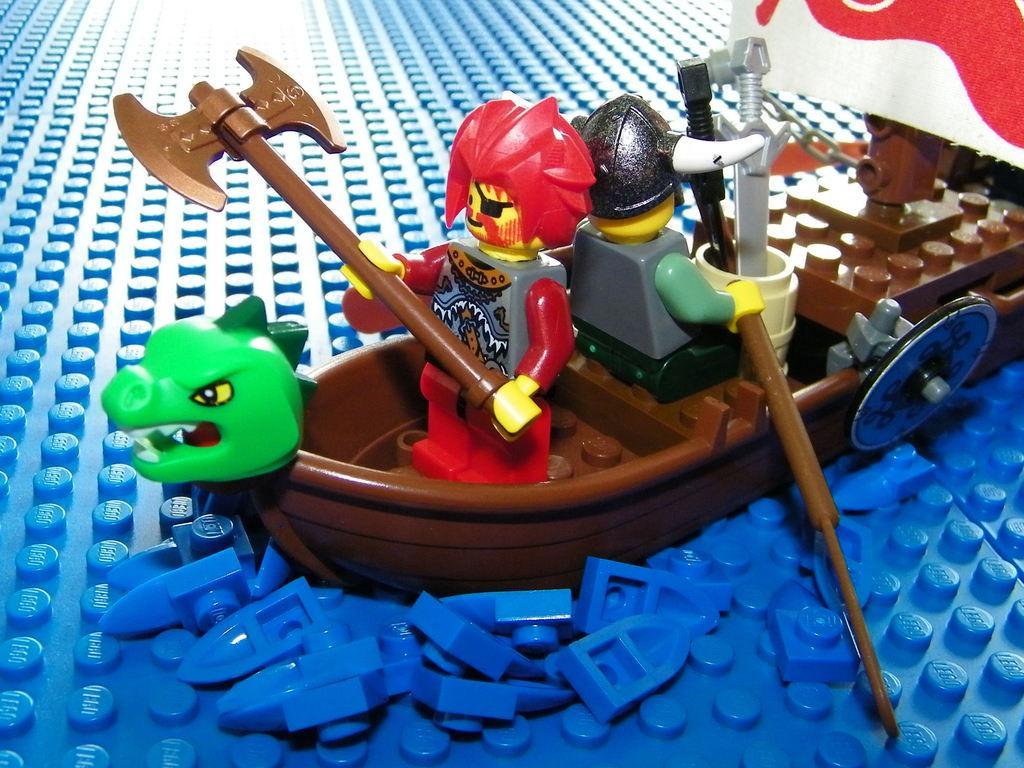Could you give a brief overview of what you see in this image? In the picture there are toys present, there is a boat and there are two men present. 